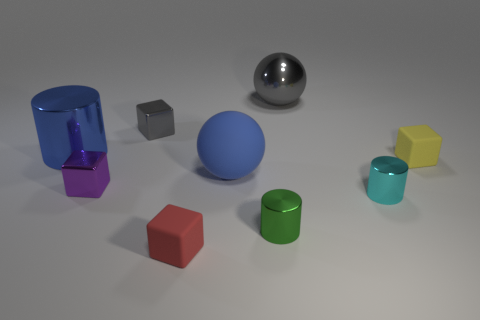How does the texture of the purple cube compare to that of the other objects? The purple cube has a metallic texture with some reflections on its surface. Compared to the other objects, its texture appears smoother and less diffuse, which could be indicative of a different material or finish. 